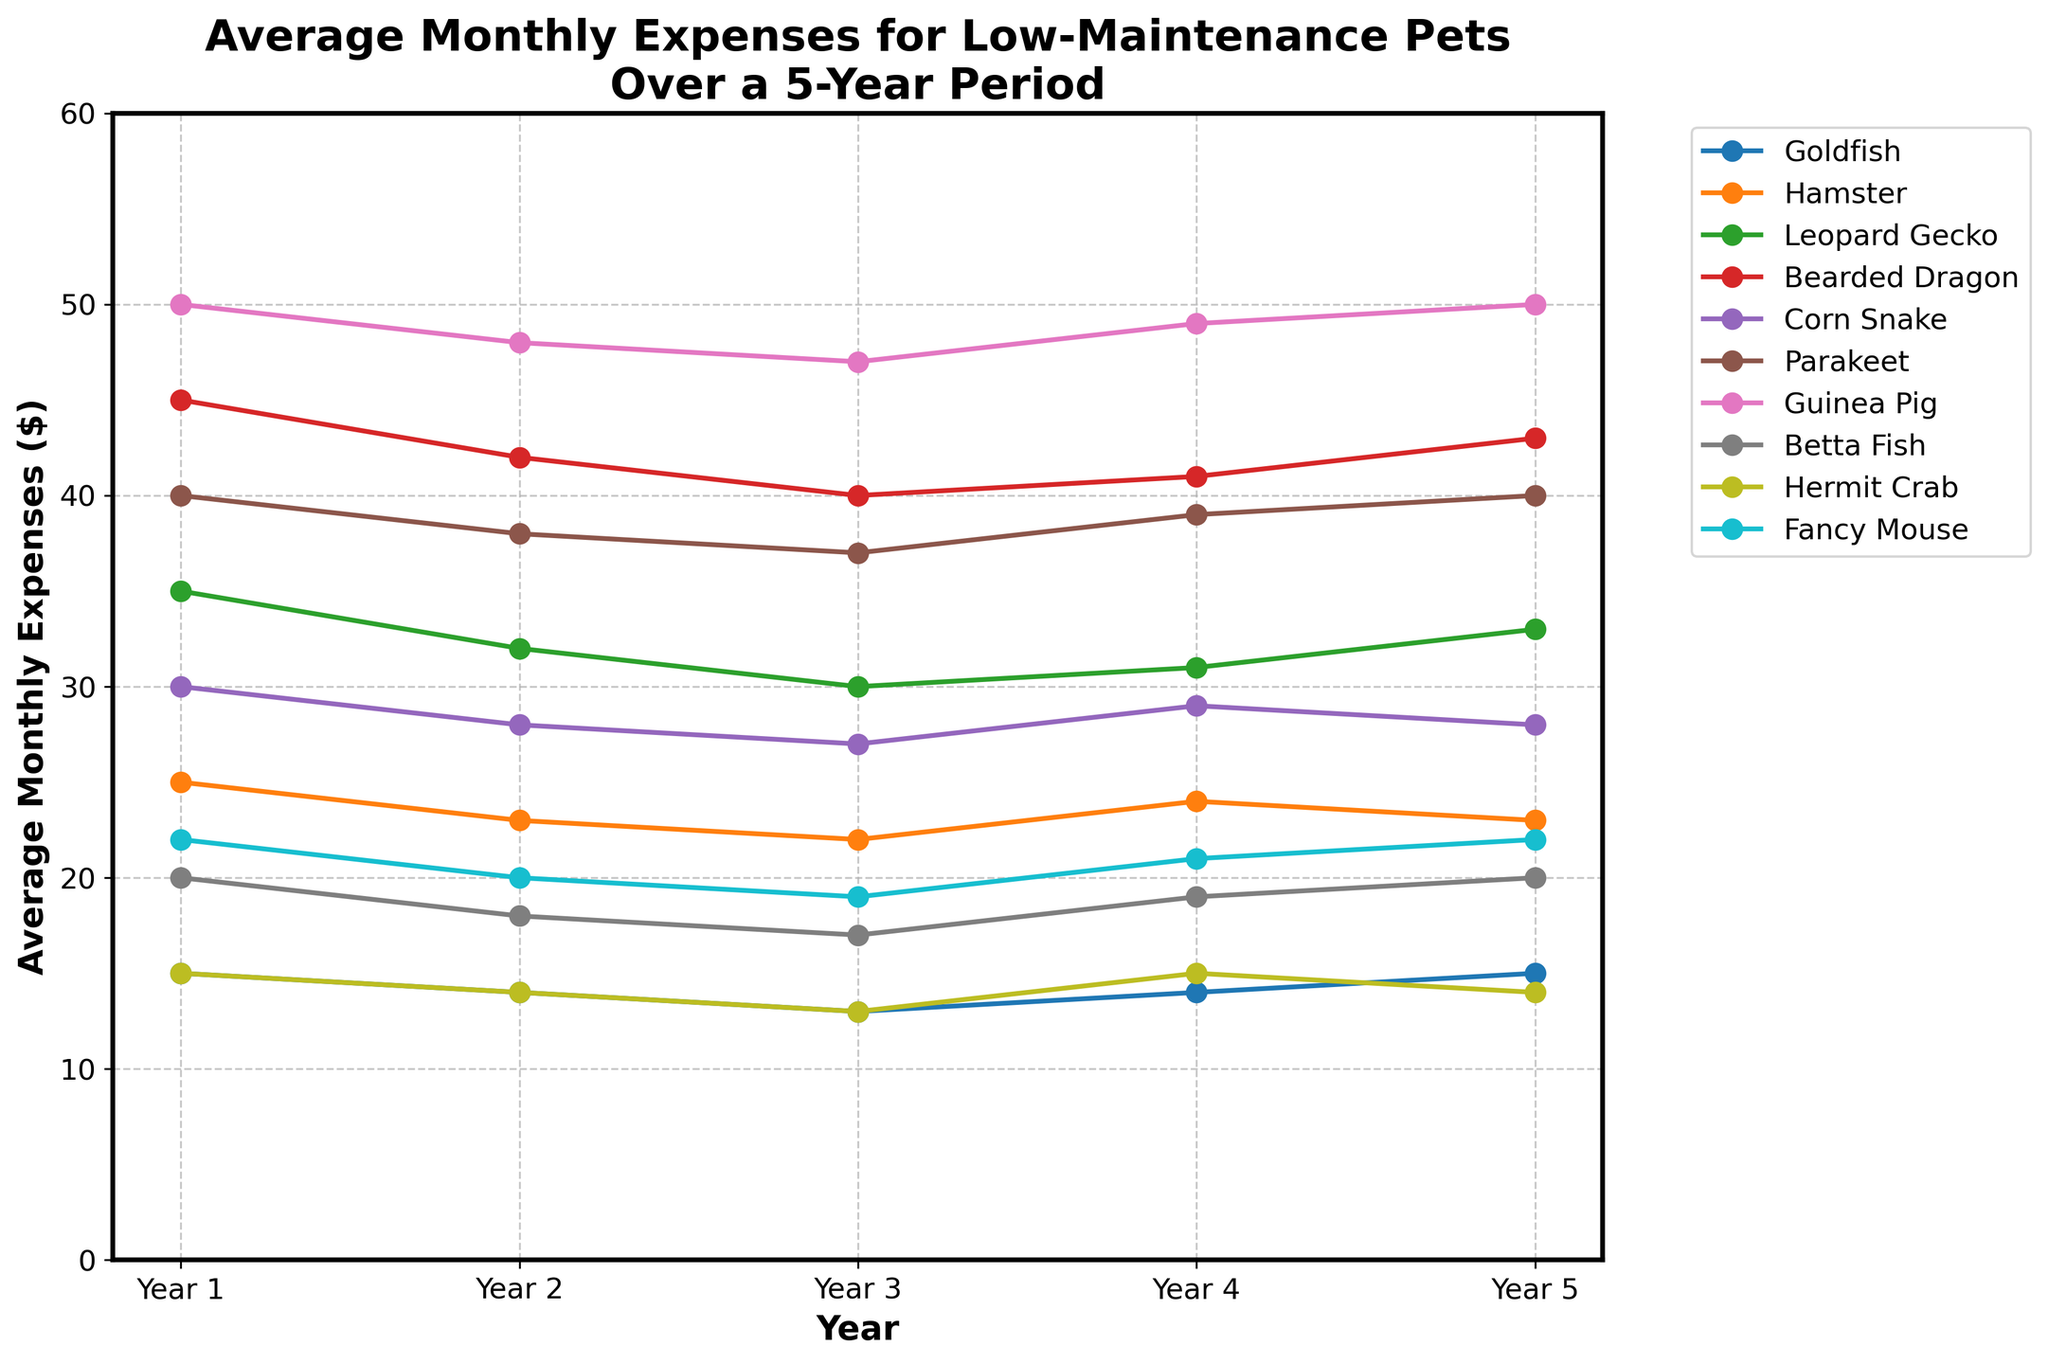What is the trend in monthly expenses for a Bearded Dragon over the 5-year period? By observing the line for Bearded Dragon, we see that the expenses decrease from Year 1 to Year 3, then it rises slightly in Year 4 and continues to rise to Year 5. Thus, the expenses exhibit a slight U-shaped trend over the period.
Answer: U-shaped Which pet shows the lowest average monthly expense consistently across all years? By comparing the lines, the Goldfish and Hermit Crab lines are consistently at the bottom. Checking the data values confirms that their expenses range between $13 and $15, lower than any other pets.
Answer: Goldfish How do the monthly expenses for Betta Fish change between Year 1 and Year 4? Observing the line for Betta Fish, the expenses decrease from $20 in Year 1 to $17 in Year 3, then increase to $19 in Year 4.
Answer: Decrease then increase In which year did the Leopard Gecko have the highest monthly expense, and what was the value? The highest point on the line for Leopard Gecko is in Year 1 with an expense of $35.
Answer: Year 1, $35 What is the difference in average monthly expenses between the Parakeet and Hamster in Year 2? The expense for Parakeet in Year 2 is $38, and for Hamster, it is $23. The difference is 38 - 23.
Answer: $15 Which pets have a consistent trend of increasing or stable average monthly expenses over the 5-year period? By examining the lines, Guinea Pig and Fancy Mouse show a gradually increasing or stable trend. Guinea Pig's expenses slightly increase overall, and Fancy Mouse's expenses decrease initially but increase consistently after Year 3.
Answer: Guinea Pig and Fancy Mouse Which pet shows the greatest fluctuation in average monthly expenses over the 5-year period? Observing the graph, the Guinea Pig line shows fluctuations between $47 and $50. Other pets do not have such a wide range of fluctuation.
Answer: Guinea Pig What is the combined monthly expense for Goldfish, Betta Fish, and Fancy Mouse in Year 3? The expense in Year 3 for Goldfish is $13, for Betta Fish is $17, and for Fancy Mouse is $19. Summing these gives 13 + 17 + 19.
Answer: $49 Which pet had a decrease in average monthly expenses for the first three years but increased in the last two years? By examining the trends, Betta Fish shows a decrease from Year 1 to Year 3 and then increases.
Answer: Betta Fish 